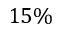<formula> <loc_0><loc_0><loc_500><loc_500>1 5 \%</formula> 